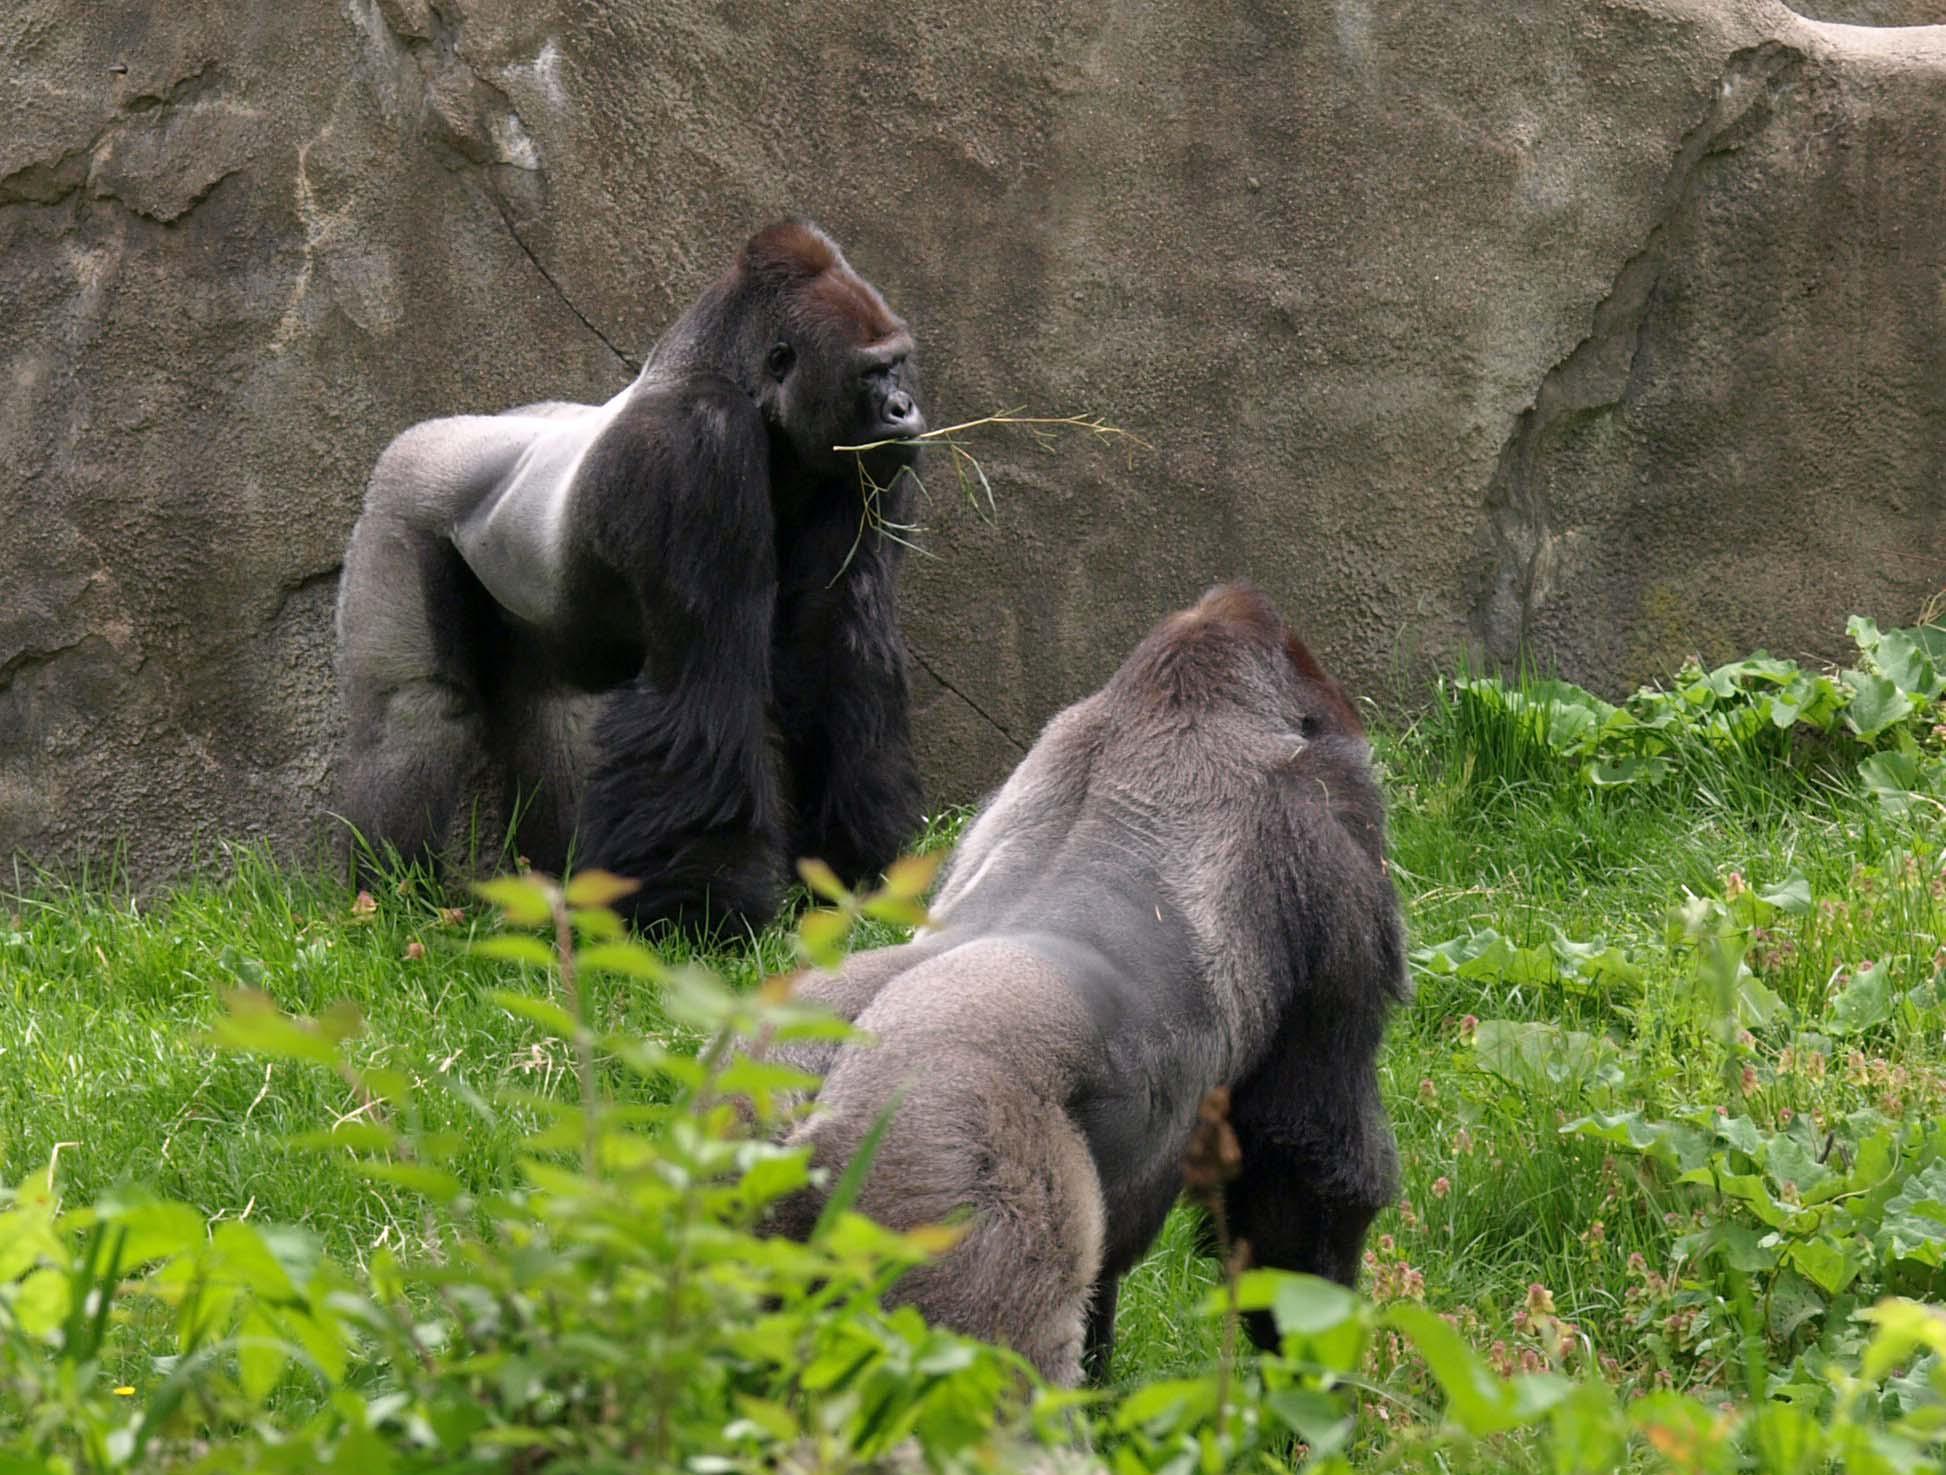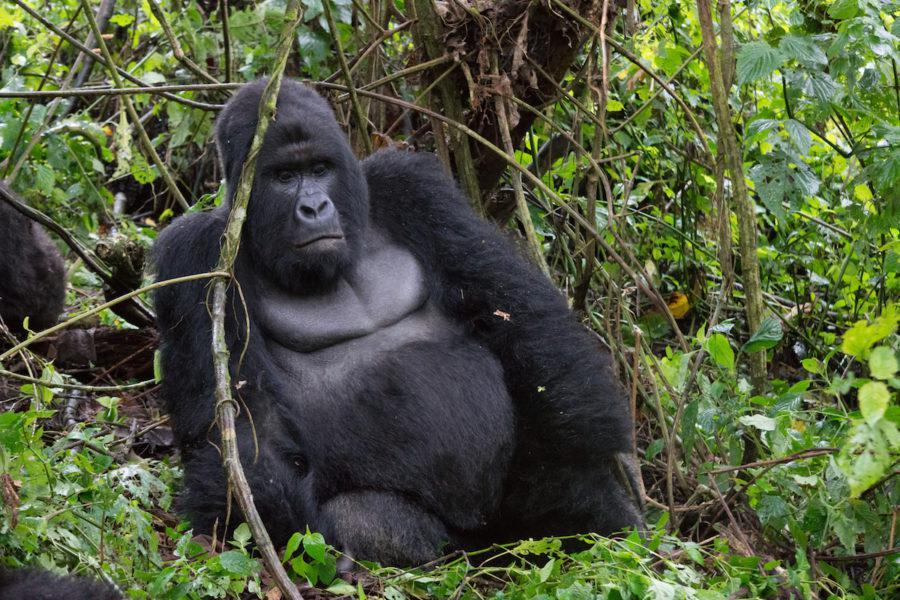The first image is the image on the left, the second image is the image on the right. Examine the images to the left and right. Is the description "An image with no more than three gorillas shows an adult sitting behind a small juvenile ape." accurate? Answer yes or no. No. The first image is the image on the left, the second image is the image on the right. Evaluate the accuracy of this statement regarding the images: "There are exactly two animals in the image on the right.". Is it true? Answer yes or no. No. 